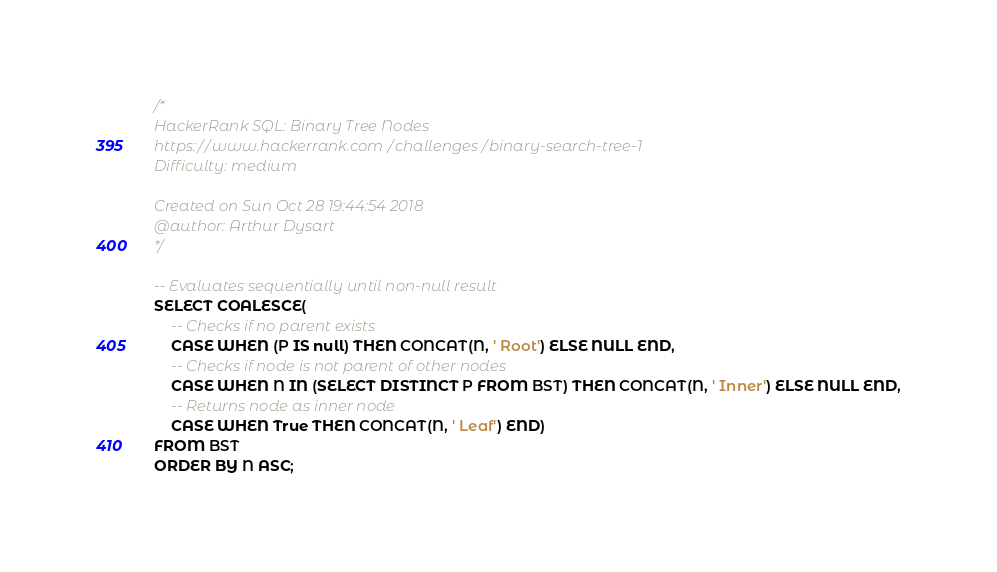Convert code to text. <code><loc_0><loc_0><loc_500><loc_500><_SQL_>/*
HackerRank SQL: Binary Tree Nodes
https://www.hackerrank.com/challenges/binary-search-tree-1
Difficulty: medium

Created on Sun Oct 28 19:44:54 2018
@author: Arthur Dysart
*/

-- Evaluates sequentially until non-null result
SELECT COALESCE(
    -- Checks if no parent exists
    CASE WHEN (P IS null) THEN CONCAT(N, ' Root') ELSE NULL END,
    -- Checks if node is not parent of other nodes 
    CASE WHEN N IN (SELECT DISTINCT P FROM BST) THEN CONCAT(N, ' Inner') ELSE NULL END,
    -- Returns node as inner node
    CASE WHEN True THEN CONCAT(N, ' Leaf') END)
FROM BST
ORDER BY N ASC;</code> 